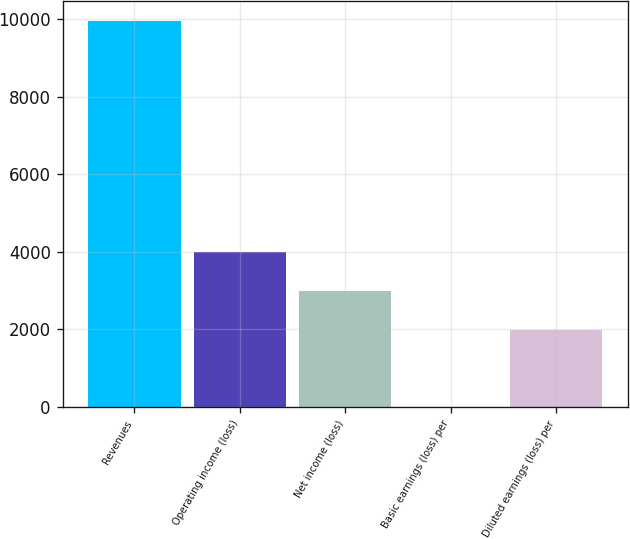Convert chart. <chart><loc_0><loc_0><loc_500><loc_500><bar_chart><fcel>Revenues<fcel>Operating income (loss)<fcel>Net income (loss)<fcel>Basic earnings (loss) per<fcel>Diluted earnings (loss) per<nl><fcel>9970<fcel>3988.75<fcel>2991.87<fcel>1.23<fcel>1994.99<nl></chart> 